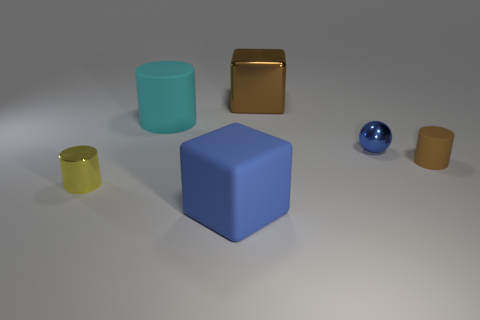Add 2 shiny blocks. How many objects exist? 8 Subtract all balls. How many objects are left? 5 Add 1 yellow metal objects. How many yellow metal objects are left? 2 Add 5 large blue rubber things. How many large blue rubber things exist? 6 Subtract 1 brown blocks. How many objects are left? 5 Subtract all large metal blocks. Subtract all big blue matte objects. How many objects are left? 4 